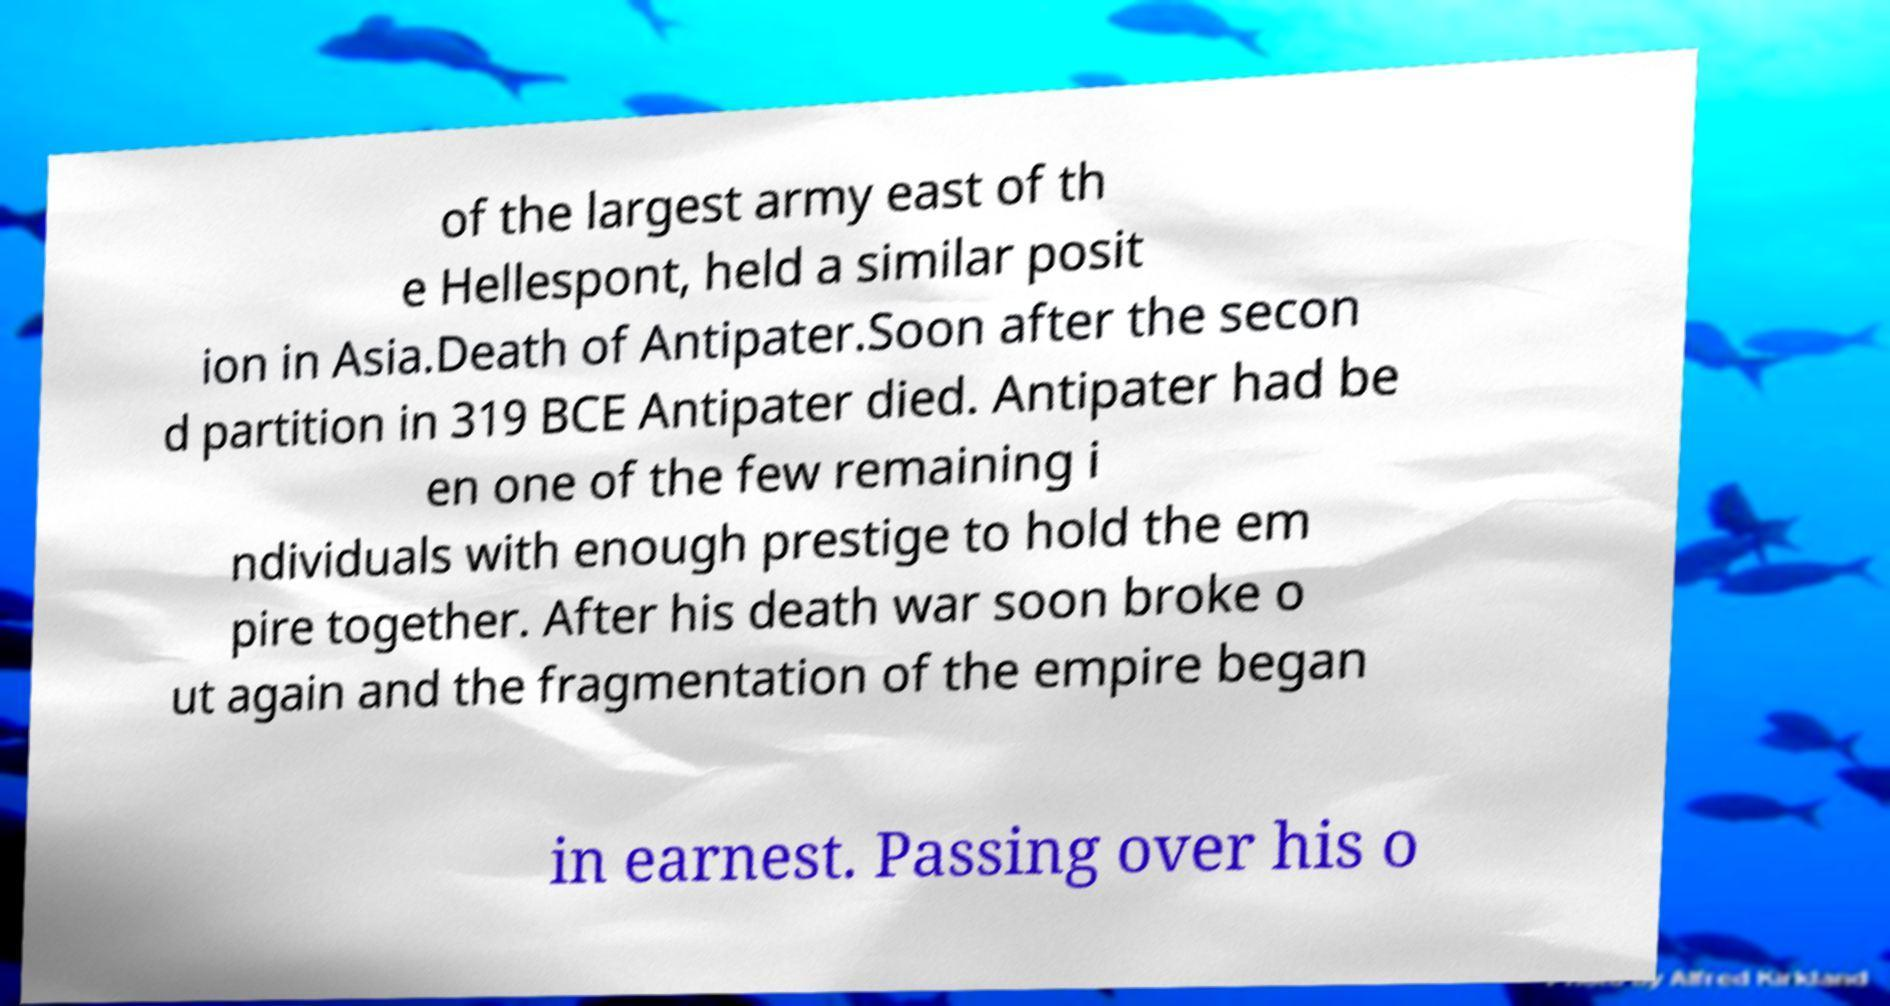Please identify and transcribe the text found in this image. of the largest army east of th e Hellespont, held a similar posit ion in Asia.Death of Antipater.Soon after the secon d partition in 319 BCE Antipater died. Antipater had be en one of the few remaining i ndividuals with enough prestige to hold the em pire together. After his death war soon broke o ut again and the fragmentation of the empire began in earnest. Passing over his o 